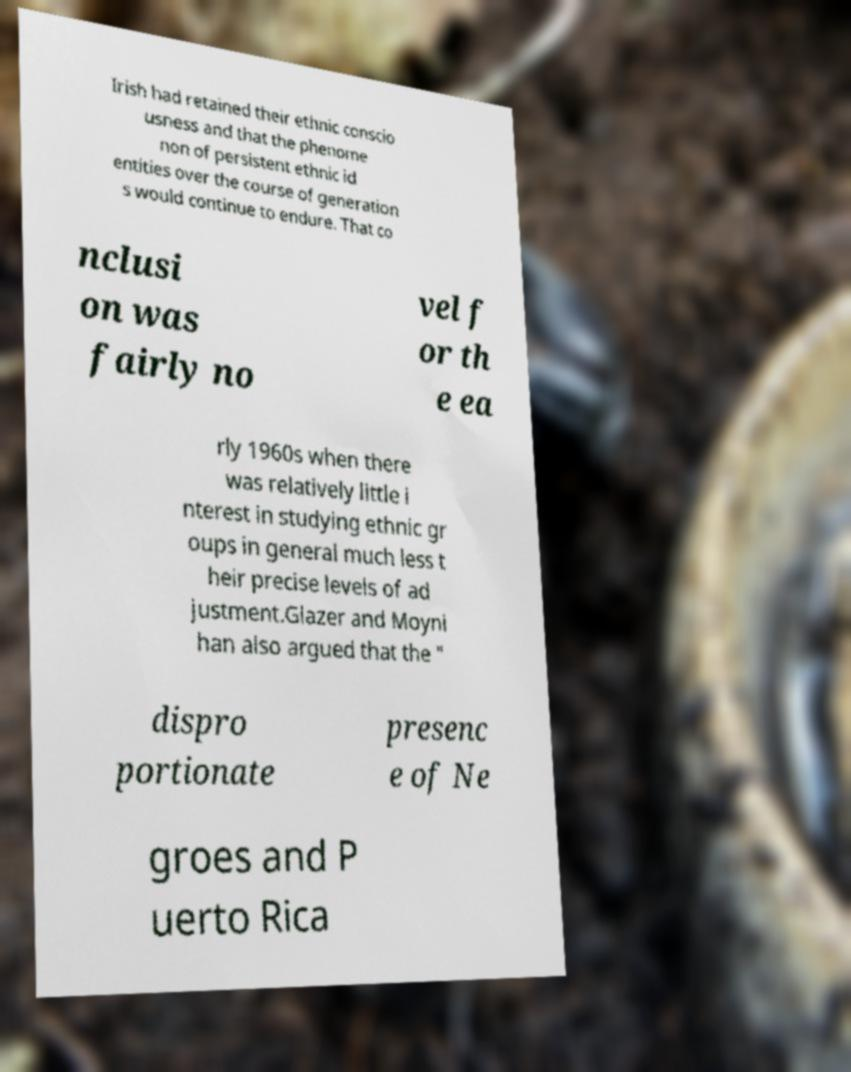I need the written content from this picture converted into text. Can you do that? Irish had retained their ethnic conscio usness and that the phenome non of persistent ethnic id entities over the course of generation s would continue to endure. That co nclusi on was fairly no vel f or th e ea rly 1960s when there was relatively little i nterest in studying ethnic gr oups in general much less t heir precise levels of ad justment.Glazer and Moyni han also argued that the " dispro portionate presenc e of Ne groes and P uerto Rica 